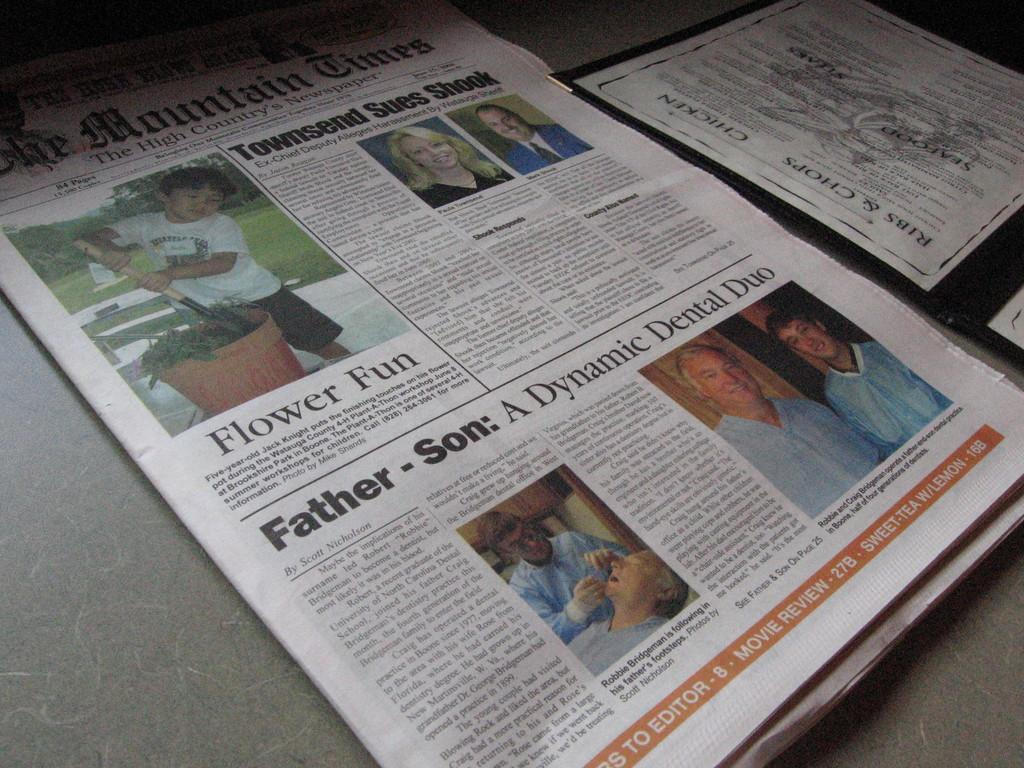<image>
Summarize the visual content of the image. Newspaper article that is saying Father and Son in a Dynamic Dental Duo. 